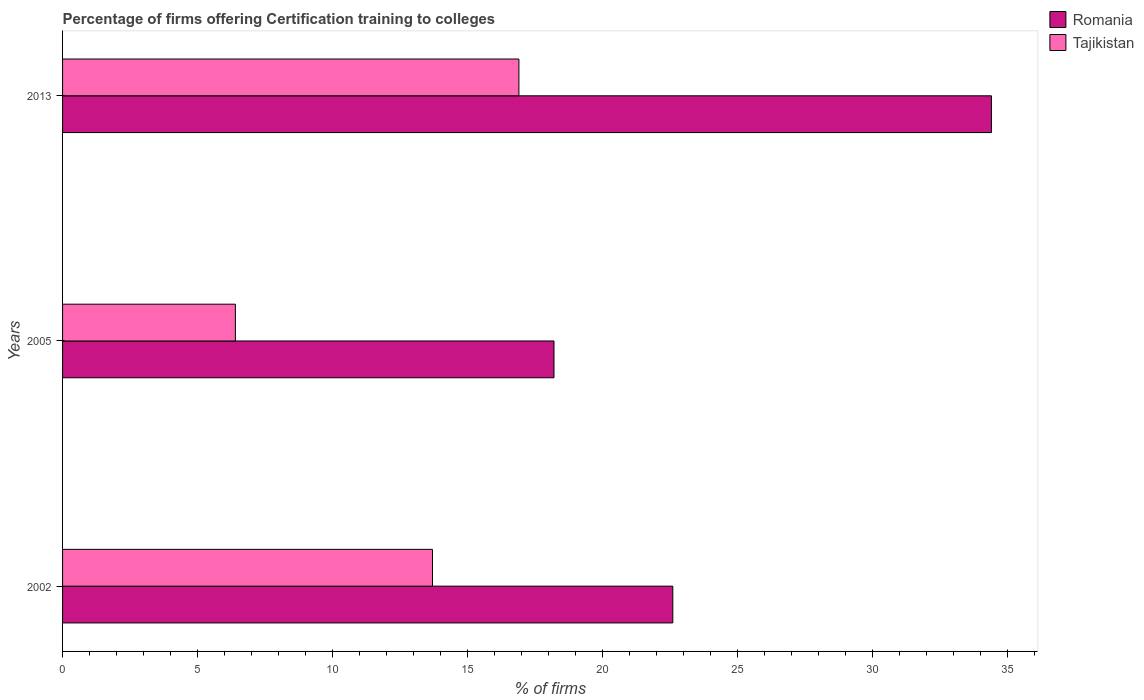Are the number of bars on each tick of the Y-axis equal?
Offer a very short reply. Yes. How many bars are there on the 3rd tick from the top?
Provide a short and direct response. 2. What is the label of the 1st group of bars from the top?
Provide a short and direct response. 2013. In how many cases, is the number of bars for a given year not equal to the number of legend labels?
Provide a short and direct response. 0. Across all years, what is the maximum percentage of firms offering certification training to colleges in Romania?
Your answer should be very brief. 34.4. Across all years, what is the minimum percentage of firms offering certification training to colleges in Tajikistan?
Offer a very short reply. 6.4. What is the total percentage of firms offering certification training to colleges in Tajikistan in the graph?
Your answer should be compact. 37. What is the difference between the percentage of firms offering certification training to colleges in Tajikistan in 2002 and that in 2013?
Ensure brevity in your answer.  -3.2. What is the difference between the percentage of firms offering certification training to colleges in Tajikistan in 2013 and the percentage of firms offering certification training to colleges in Romania in 2002?
Give a very brief answer. -5.7. What is the average percentage of firms offering certification training to colleges in Tajikistan per year?
Offer a very short reply. 12.33. In the year 2002, what is the difference between the percentage of firms offering certification training to colleges in Tajikistan and percentage of firms offering certification training to colleges in Romania?
Make the answer very short. -8.9. In how many years, is the percentage of firms offering certification training to colleges in Romania greater than 5 %?
Give a very brief answer. 3. What is the ratio of the percentage of firms offering certification training to colleges in Romania in 2002 to that in 2013?
Your answer should be very brief. 0.66. Is the percentage of firms offering certification training to colleges in Tajikistan in 2002 less than that in 2005?
Keep it short and to the point. No. Is the difference between the percentage of firms offering certification training to colleges in Tajikistan in 2002 and 2005 greater than the difference between the percentage of firms offering certification training to colleges in Romania in 2002 and 2005?
Offer a terse response. Yes. What is the difference between the highest and the second highest percentage of firms offering certification training to colleges in Tajikistan?
Your answer should be very brief. 3.2. What is the difference between the highest and the lowest percentage of firms offering certification training to colleges in Tajikistan?
Provide a succinct answer. 10.5. In how many years, is the percentage of firms offering certification training to colleges in Romania greater than the average percentage of firms offering certification training to colleges in Romania taken over all years?
Provide a succinct answer. 1. Is the sum of the percentage of firms offering certification training to colleges in Romania in 2005 and 2013 greater than the maximum percentage of firms offering certification training to colleges in Tajikistan across all years?
Your answer should be very brief. Yes. What does the 2nd bar from the top in 2013 represents?
Provide a short and direct response. Romania. What does the 1st bar from the bottom in 2002 represents?
Your answer should be very brief. Romania. How many years are there in the graph?
Your response must be concise. 3. Are the values on the major ticks of X-axis written in scientific E-notation?
Ensure brevity in your answer.  No. Does the graph contain grids?
Offer a very short reply. No. Where does the legend appear in the graph?
Give a very brief answer. Top right. How many legend labels are there?
Provide a short and direct response. 2. What is the title of the graph?
Your answer should be compact. Percentage of firms offering Certification training to colleges. Does "Guinea-Bissau" appear as one of the legend labels in the graph?
Offer a very short reply. No. What is the label or title of the X-axis?
Make the answer very short. % of firms. What is the % of firms of Romania in 2002?
Your answer should be very brief. 22.6. What is the % of firms of Tajikistan in 2002?
Offer a very short reply. 13.7. What is the % of firms of Romania in 2005?
Make the answer very short. 18.2. What is the % of firms in Tajikistan in 2005?
Provide a short and direct response. 6.4. What is the % of firms in Romania in 2013?
Your answer should be compact. 34.4. Across all years, what is the maximum % of firms in Romania?
Provide a succinct answer. 34.4. Across all years, what is the maximum % of firms of Tajikistan?
Give a very brief answer. 16.9. What is the total % of firms in Romania in the graph?
Ensure brevity in your answer.  75.2. What is the total % of firms in Tajikistan in the graph?
Make the answer very short. 37. What is the difference between the % of firms in Romania in 2005 and that in 2013?
Provide a succinct answer. -16.2. What is the difference between the % of firms in Tajikistan in 2005 and that in 2013?
Make the answer very short. -10.5. What is the difference between the % of firms of Romania in 2005 and the % of firms of Tajikistan in 2013?
Your response must be concise. 1.3. What is the average % of firms in Romania per year?
Provide a short and direct response. 25.07. What is the average % of firms in Tajikistan per year?
Provide a succinct answer. 12.33. In the year 2005, what is the difference between the % of firms in Romania and % of firms in Tajikistan?
Keep it short and to the point. 11.8. What is the ratio of the % of firms in Romania in 2002 to that in 2005?
Provide a succinct answer. 1.24. What is the ratio of the % of firms of Tajikistan in 2002 to that in 2005?
Ensure brevity in your answer.  2.14. What is the ratio of the % of firms in Romania in 2002 to that in 2013?
Your answer should be very brief. 0.66. What is the ratio of the % of firms in Tajikistan in 2002 to that in 2013?
Provide a short and direct response. 0.81. What is the ratio of the % of firms of Romania in 2005 to that in 2013?
Your response must be concise. 0.53. What is the ratio of the % of firms in Tajikistan in 2005 to that in 2013?
Give a very brief answer. 0.38. What is the difference between the highest and the second highest % of firms in Tajikistan?
Provide a short and direct response. 3.2. What is the difference between the highest and the lowest % of firms of Romania?
Make the answer very short. 16.2. 